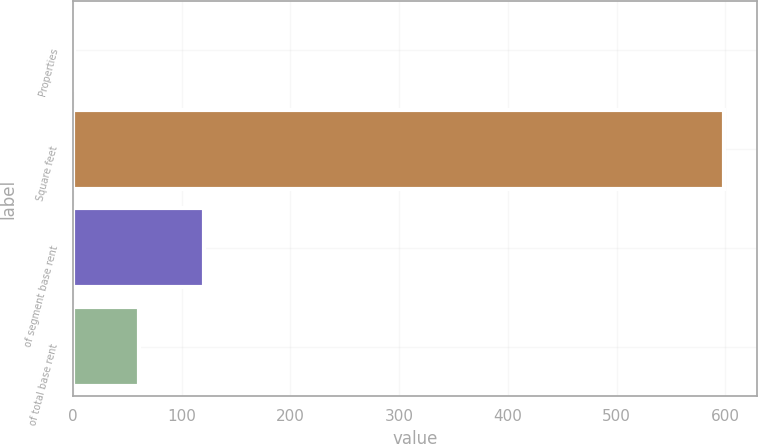<chart> <loc_0><loc_0><loc_500><loc_500><bar_chart><fcel>Properties<fcel>Square feet<fcel>of segment base rent<fcel>of total base rent<nl><fcel>1<fcel>599<fcel>120.6<fcel>60.8<nl></chart> 